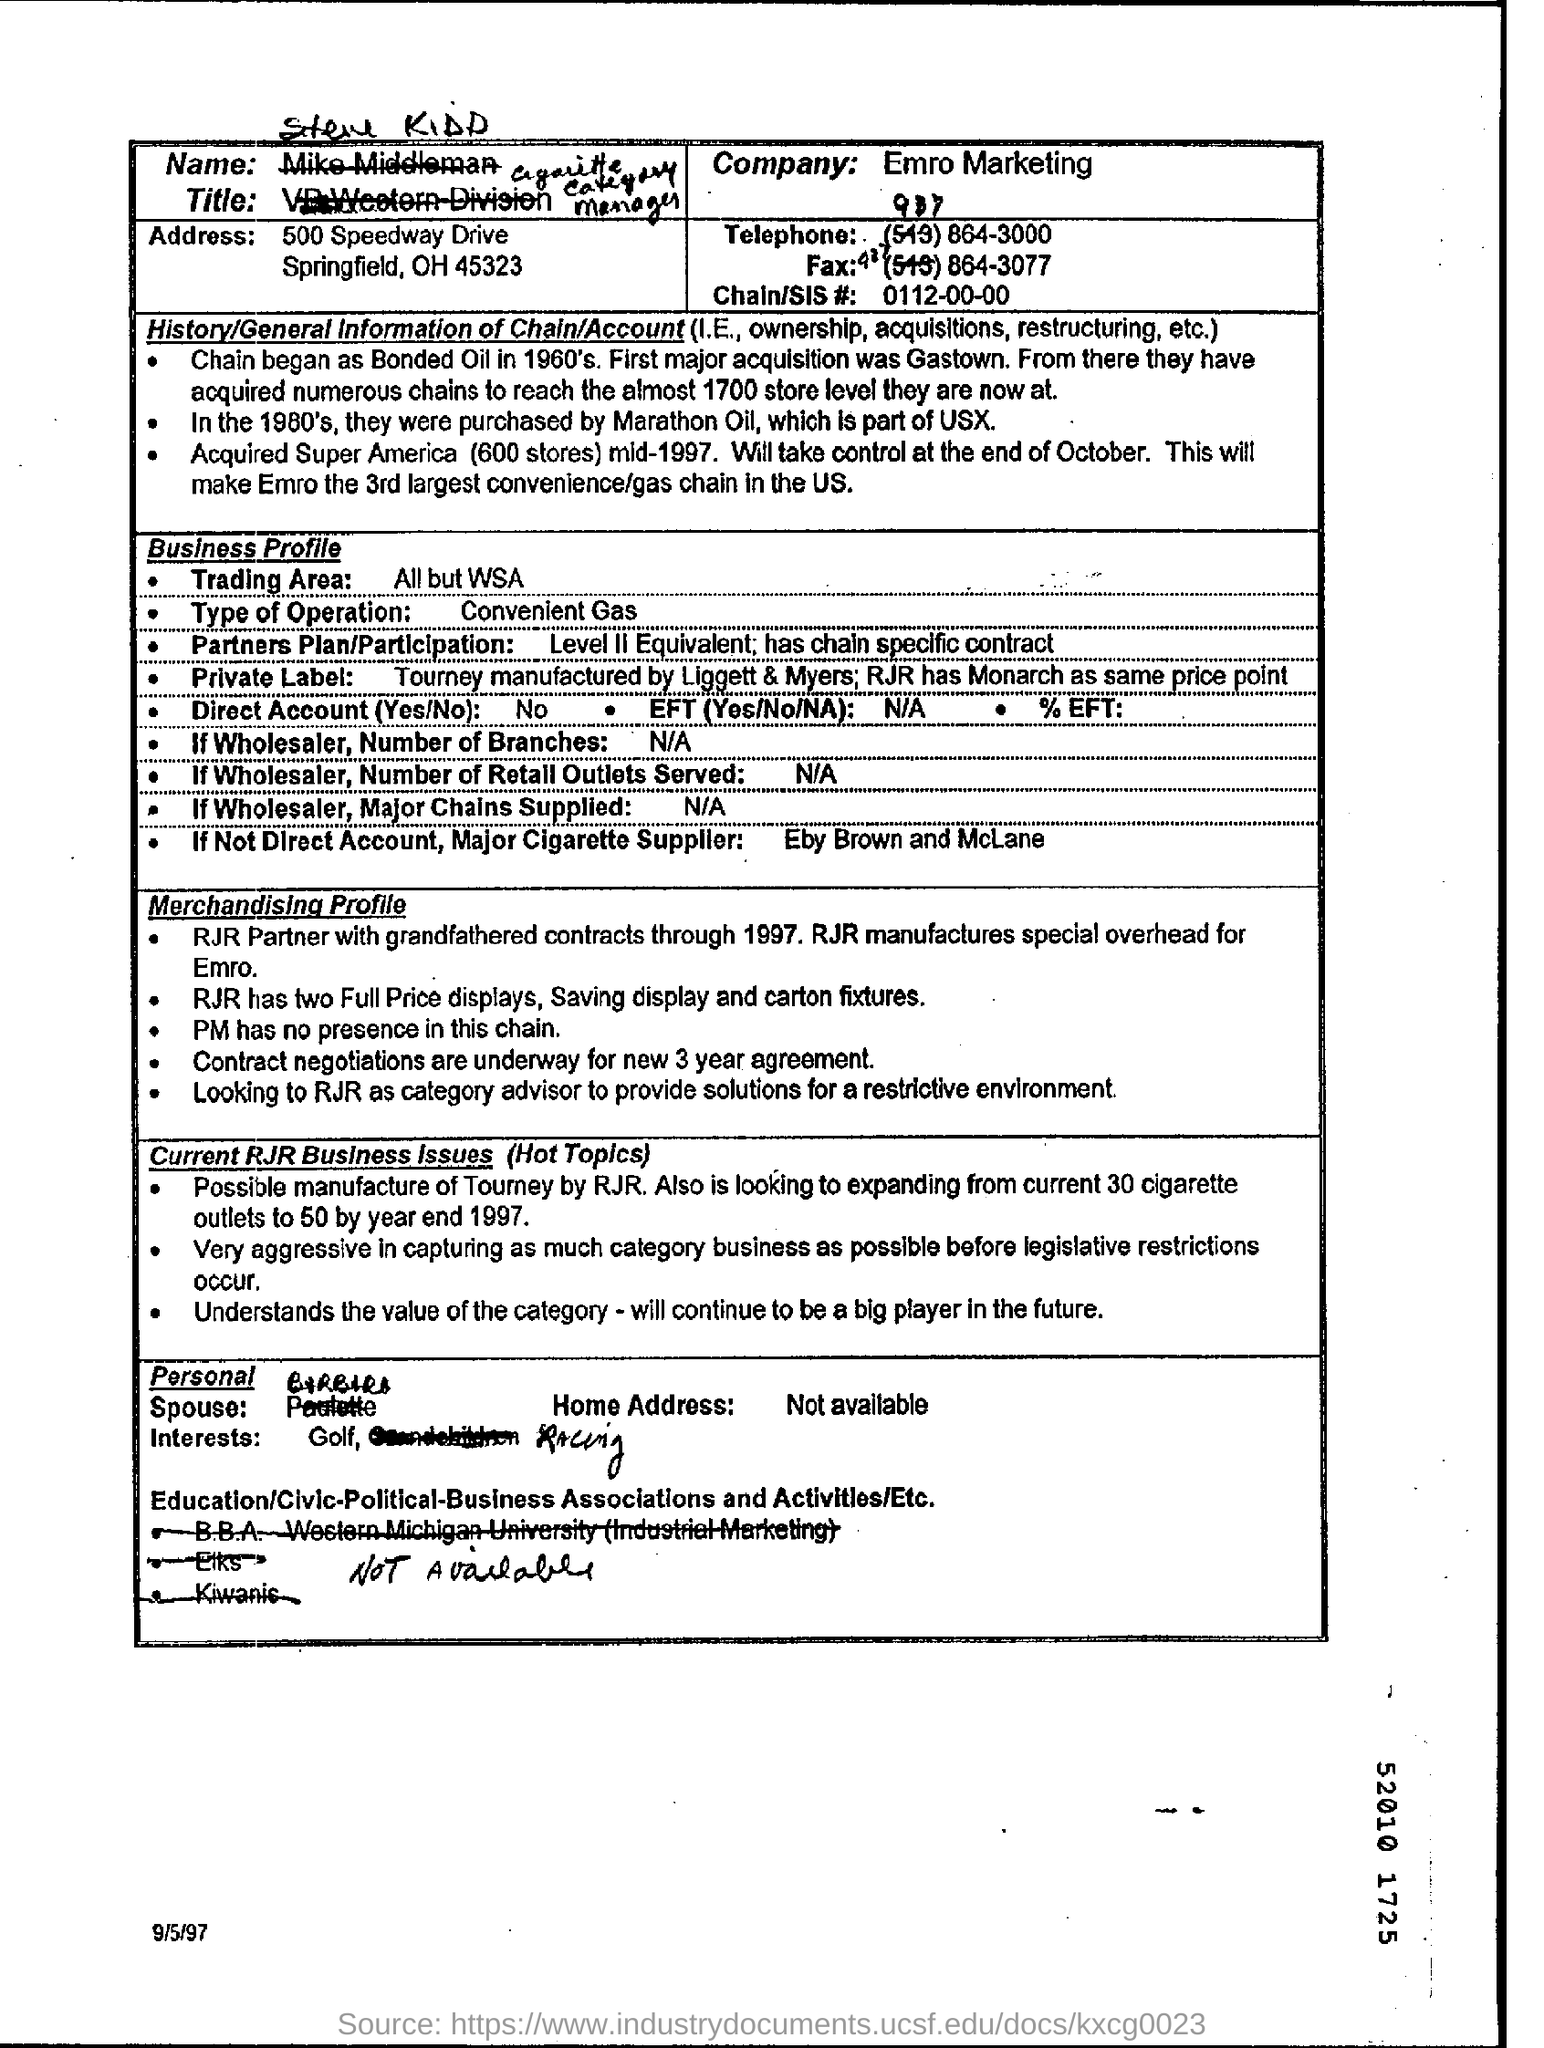Which is the trading area?
Provide a succinct answer. All but WSA. What is the type of operation?
Keep it short and to the point. Convenient Gas. Is it direct account?
Provide a succinct answer. No. 